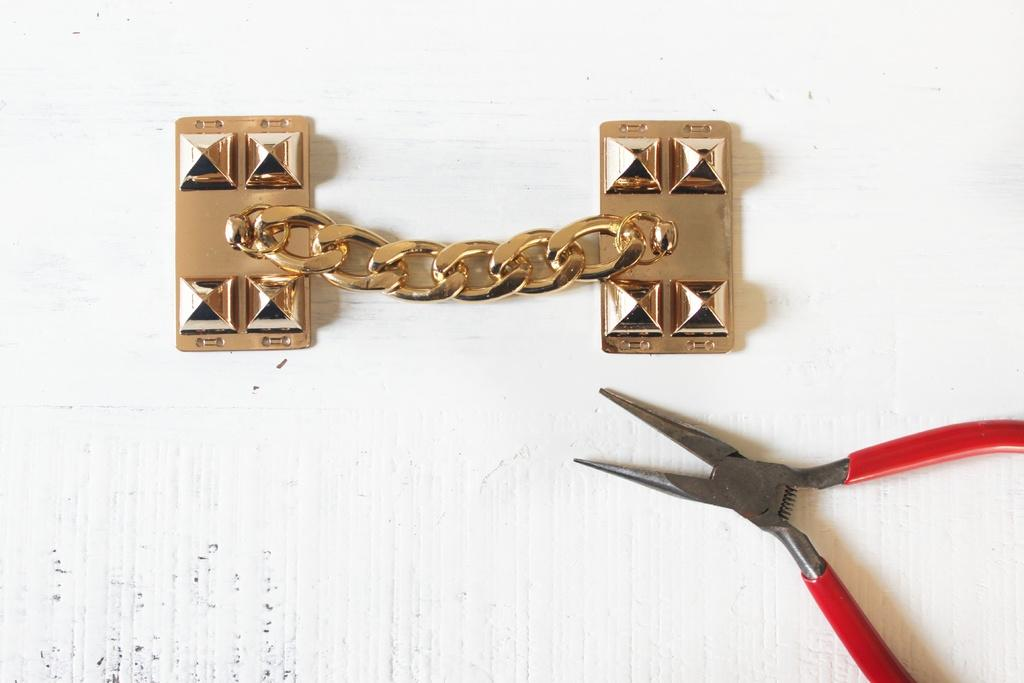What type of object is made of metal in the image? There is a metal object in the image. What is the purpose of the tool visible in the image? There is a tool in the image, but the specific purpose cannot be determined from the facts provided. What can be seen in the background of the image? There is a wall visible in the background of the image. How many hens are sitting on the nail in the image? There are no hens or nails present in the image. What type of truck is visible in the image? There is no truck present in the image. 